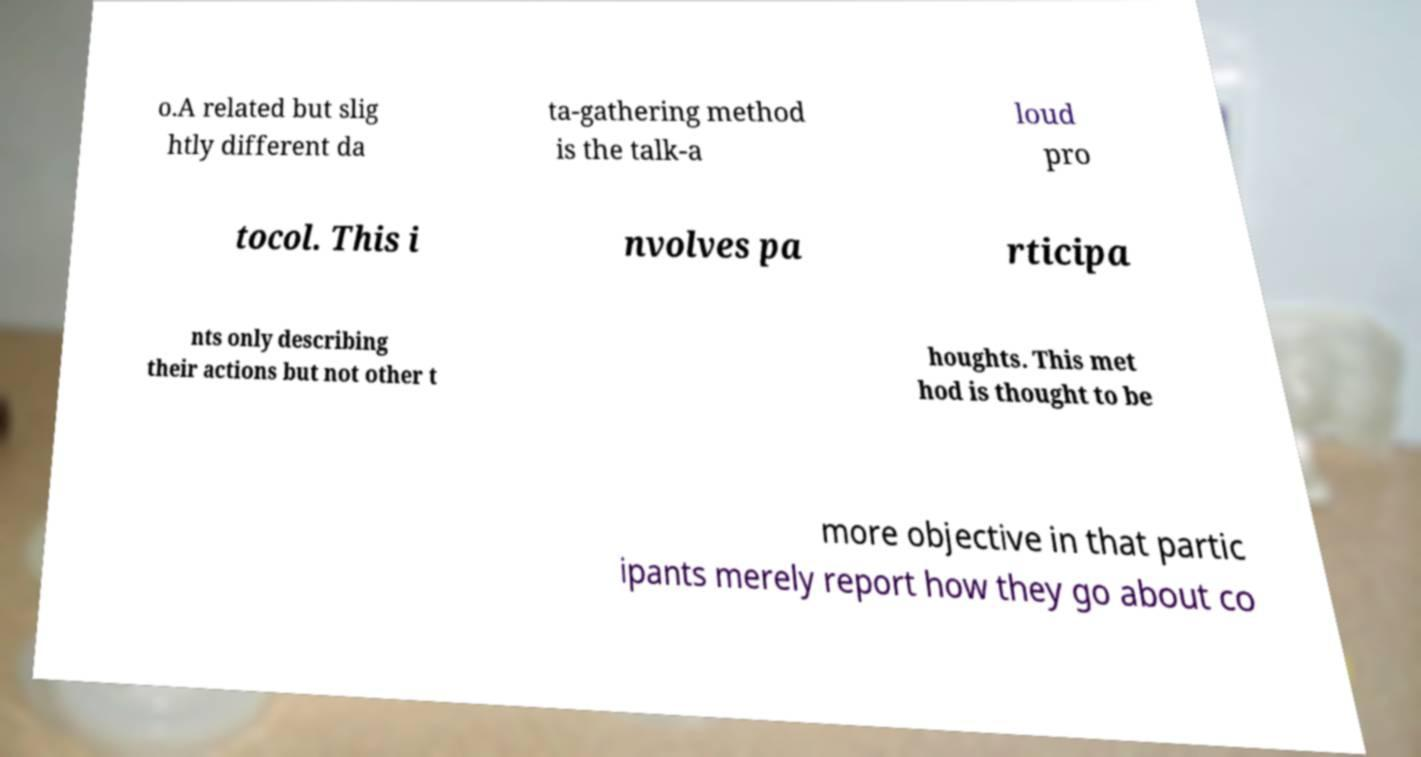Could you assist in decoding the text presented in this image and type it out clearly? o.A related but slig htly different da ta-gathering method is the talk-a loud pro tocol. This i nvolves pa rticipa nts only describing their actions but not other t houghts. This met hod is thought to be more objective in that partic ipants merely report how they go about co 